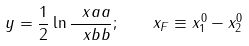<formula> <loc_0><loc_0><loc_500><loc_500>y = \frac { 1 } { 2 } \ln \frac { \ x a a } { \ x b b } ; \quad x _ { F } \equiv x _ { 1 } ^ { 0 } - x _ { 2 } ^ { 0 }</formula> 